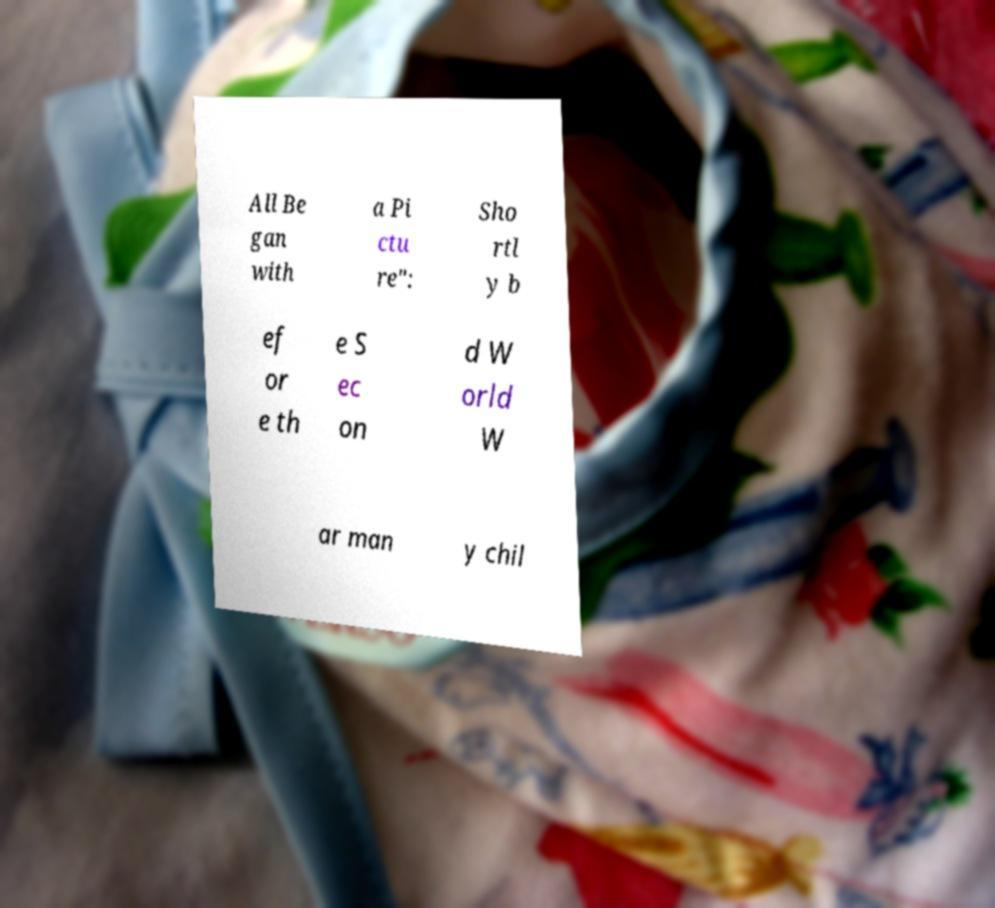Can you accurately transcribe the text from the provided image for me? All Be gan with a Pi ctu re": Sho rtl y b ef or e th e S ec on d W orld W ar man y chil 